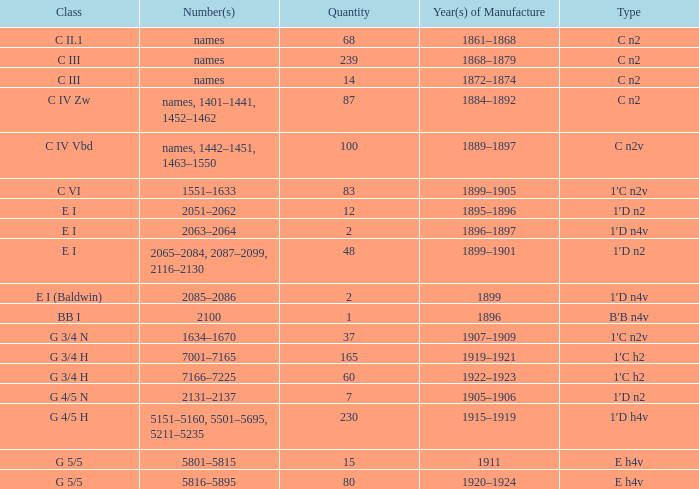In which year(s) of creation does the quantity surpass 60, and the digit(s) fall between 7001 and 7165? 1919–1921. 